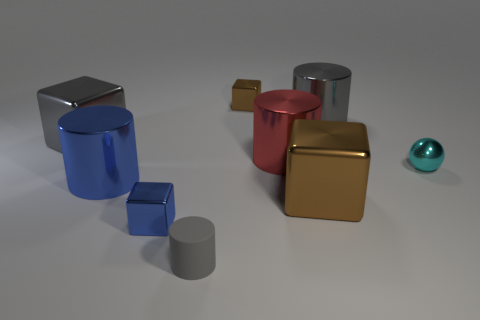Subtract all blue blocks. How many blocks are left? 3 Subtract all metallic cylinders. How many cylinders are left? 1 Add 1 brown metal things. How many objects exist? 10 Subtract all blue metallic objects. Subtract all large blue cylinders. How many objects are left? 6 Add 8 red objects. How many red objects are left? 9 Add 6 large brown things. How many large brown things exist? 7 Subtract 0 green cylinders. How many objects are left? 9 Subtract all cylinders. How many objects are left? 5 Subtract 4 cubes. How many cubes are left? 0 Subtract all yellow balls. Subtract all gray cubes. How many balls are left? 1 